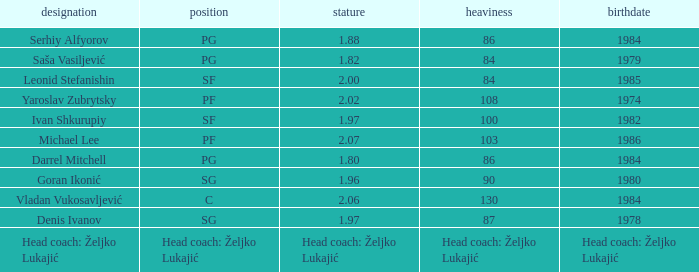What was the weight of Serhiy Alfyorov? 86.0. 